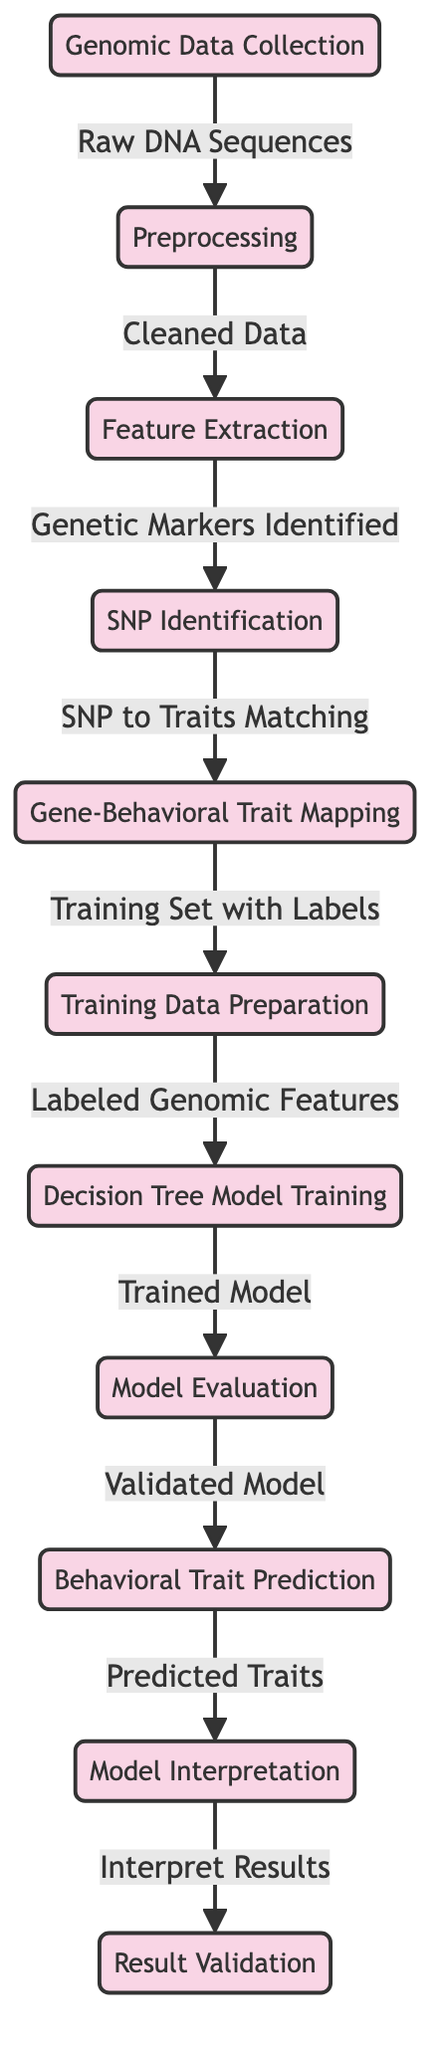What is the first step in the process? The first step is "Genomic Data Collection," which is indicated as the starting node in the diagram.
Answer: Genomic Data Collection How many nodes are there in total? Counting each distinct step represented in the diagram, there are a total of 11 nodes.
Answer: 11 What comes after "Preprocessing"? The step that follows "Preprocessing" is "Feature Extraction," which is the immediate next node connected in the flow.
Answer: Feature Extraction What type of data is produced after "SNP Identification"? After "SNP Identification," the output is "Gene-Behavioral Trait Mapping," which indicates what type of data is produced following that step.
Answer: Gene-Behavioral Trait Mapping Which step is directly linked to "Labeled Genomic Features"? The step directly linked to "Labeled Genomic Features" is "Decision Tree Model Training," as indicated by the arrow connecting these two nodes in the flow.
Answer: Decision Tree Model Training Which nodes lead to "Behavioral Trait Prediction"? To reach "Behavioral Trait Prediction," you can follow the nodes "Model Evaluation" and "Trained Model," both of which are prerequisites in the process.
Answer: Model Evaluation, Trained Model How does the model obtain validated results? The model obtains validated results through the "Model Evaluation" step, which ensures that the model is validated prior to predicting traits.
Answer: Model Evaluation What is the final output of the diagram? The final output of the entire process represented in the diagram is "Predicted Traits" leading to "Interpret Results" as the last node in the flow.
Answer: Predicted Traits What is the relationship between "Training Data Preparation" and "Decision Tree Model Training"? "Training Data Preparation" is the input that feeds into "Decision Tree Model Training," indicating it is a prerequisite for building the model.
Answer: Input for training What is the purpose of the "Model Interpretation" step? The purpose of the "Model Interpretation" step is to clarify and analyze the outcomes produced from the "Behavioral Trait Prediction," therefore making sense of the predicted results.
Answer: Clarifying outcomes 